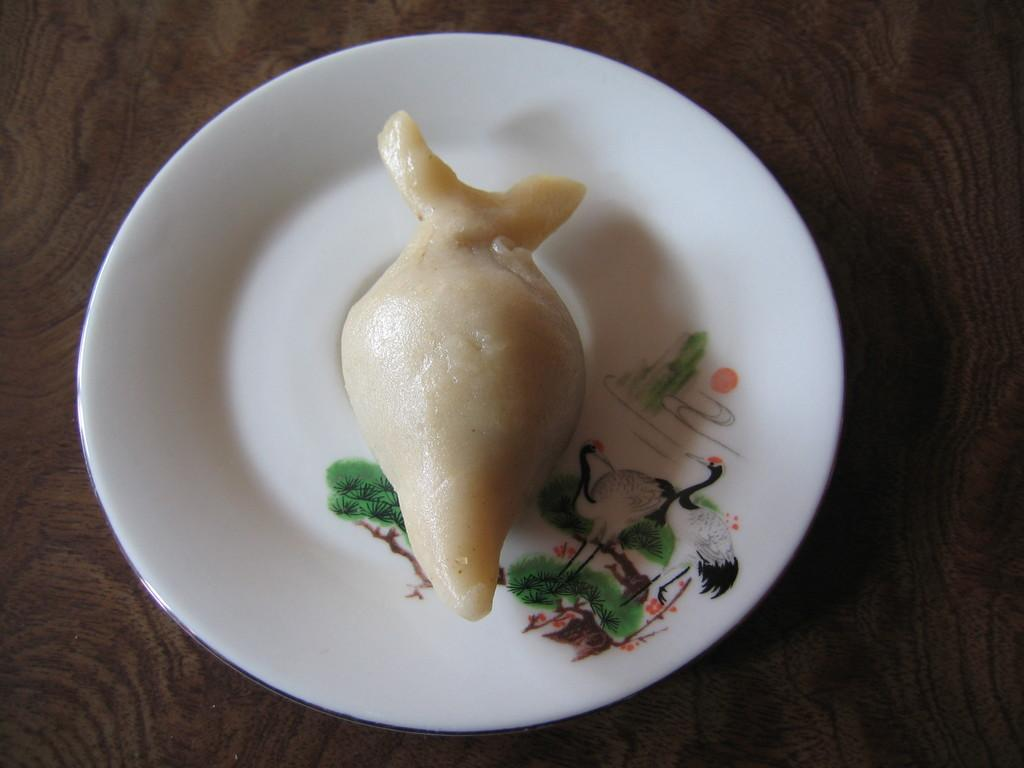What is on the plate that is visible in the image? There is a food item on a plate in the image. Where is the plate located? The plate is on a wooden board. How many parcels are being delivered to the rabbit in the image? There is no rabbit or parcel present in the image. 